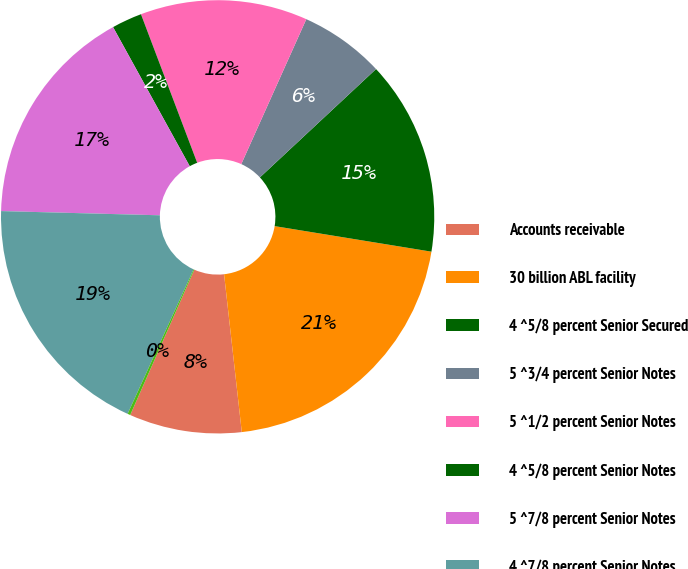Convert chart. <chart><loc_0><loc_0><loc_500><loc_500><pie_chart><fcel>Accounts receivable<fcel>30 billion ABL facility<fcel>4 ^5/8 percent Senior Secured<fcel>5 ^3/4 percent Senior Notes<fcel>5 ^1/2 percent Senior Notes<fcel>4 ^5/8 percent Senior Notes<fcel>5 ^7/8 percent Senior Notes<fcel>4 ^7/8 percent Senior Notes<fcel>Capital leases<nl><fcel>8.39%<fcel>20.65%<fcel>14.52%<fcel>6.34%<fcel>12.47%<fcel>2.26%<fcel>16.56%<fcel>18.6%<fcel>0.21%<nl></chart> 